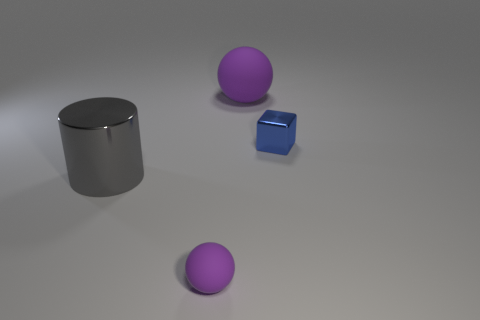Add 1 large cyan balls. How many objects exist? 5 Subtract all cylinders. How many objects are left? 3 Subtract 0 gray spheres. How many objects are left? 4 Subtract all brown cubes. Subtract all big purple rubber things. How many objects are left? 3 Add 4 large metal things. How many large metal things are left? 5 Add 3 big gray rubber cylinders. How many big gray rubber cylinders exist? 3 